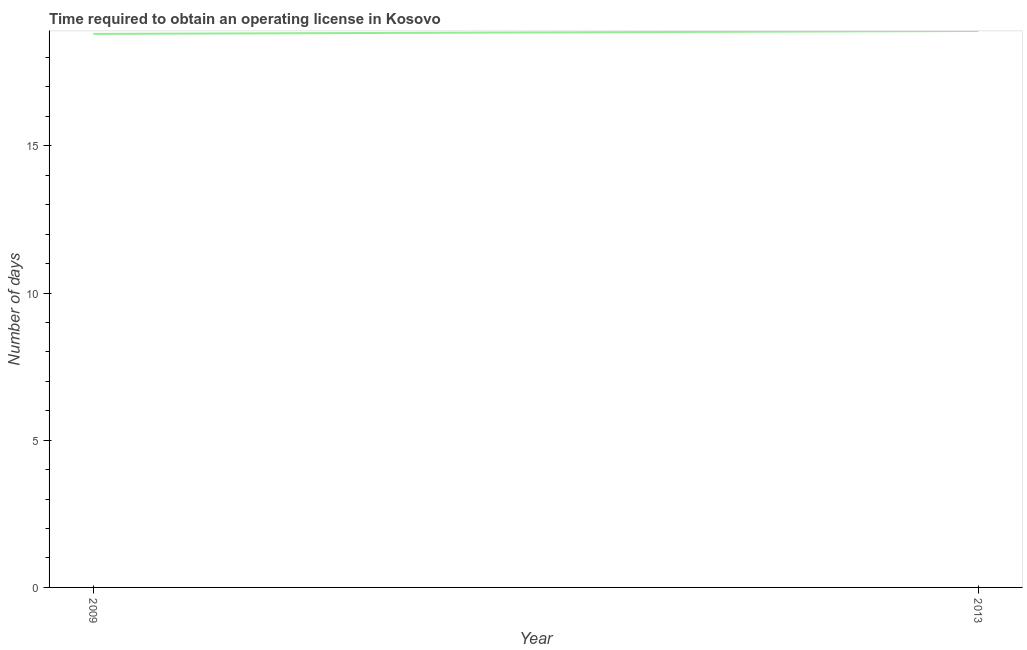In which year was the number of days to obtain operating license maximum?
Ensure brevity in your answer.  2013. In which year was the number of days to obtain operating license minimum?
Give a very brief answer. 2009. What is the sum of the number of days to obtain operating license?
Provide a succinct answer. 37.7. What is the difference between the number of days to obtain operating license in 2009 and 2013?
Provide a short and direct response. -0.1. What is the average number of days to obtain operating license per year?
Provide a short and direct response. 18.85. What is the median number of days to obtain operating license?
Make the answer very short. 18.85. In how many years, is the number of days to obtain operating license greater than 2 days?
Your answer should be very brief. 2. Do a majority of the years between 2013 and 2009 (inclusive) have number of days to obtain operating license greater than 7 days?
Your response must be concise. No. What is the ratio of the number of days to obtain operating license in 2009 to that in 2013?
Keep it short and to the point. 0.99. How many lines are there?
Your response must be concise. 1. What is the difference between two consecutive major ticks on the Y-axis?
Keep it short and to the point. 5. Are the values on the major ticks of Y-axis written in scientific E-notation?
Offer a very short reply. No. What is the title of the graph?
Provide a short and direct response. Time required to obtain an operating license in Kosovo. What is the label or title of the Y-axis?
Provide a short and direct response. Number of days. What is the Number of days of 2013?
Offer a terse response. 18.9. 